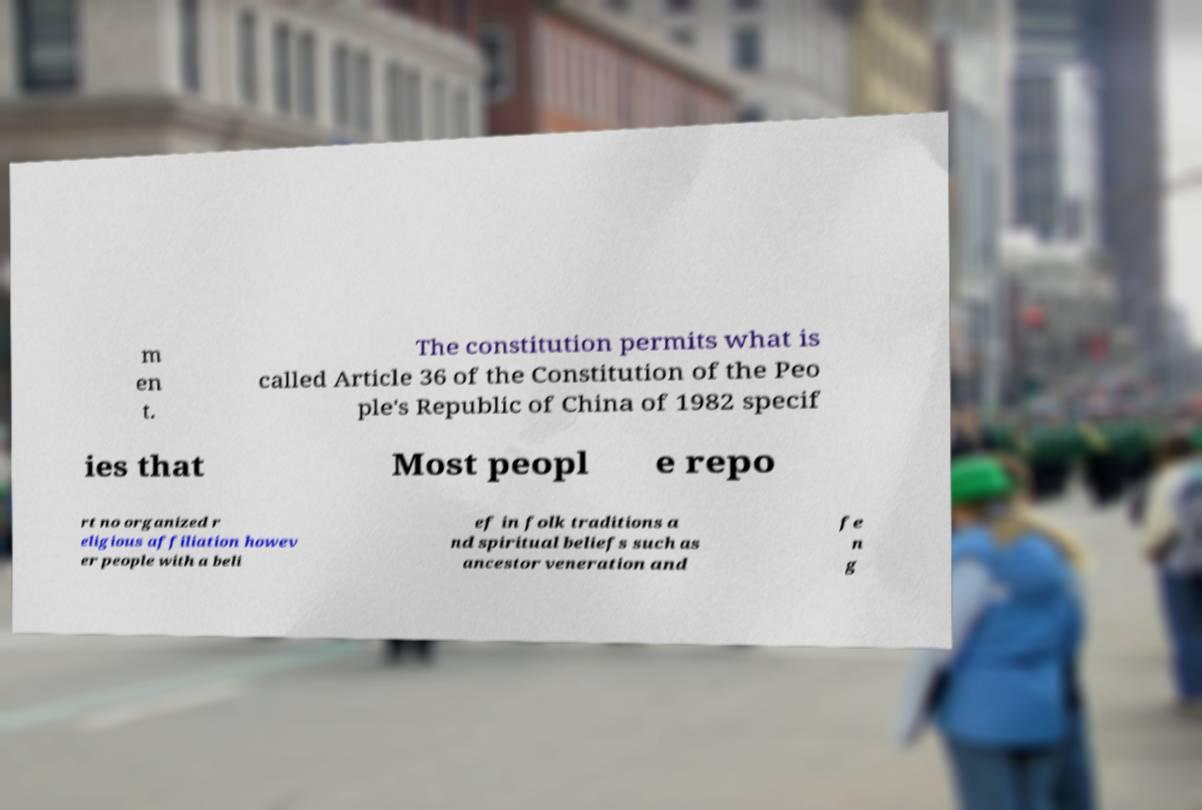Please read and relay the text visible in this image. What does it say? m en t. The constitution permits what is called Article 36 of the Constitution of the Peo ple's Republic of China of 1982 specif ies that Most peopl e repo rt no organized r eligious affiliation howev er people with a beli ef in folk traditions a nd spiritual beliefs such as ancestor veneration and fe n g 